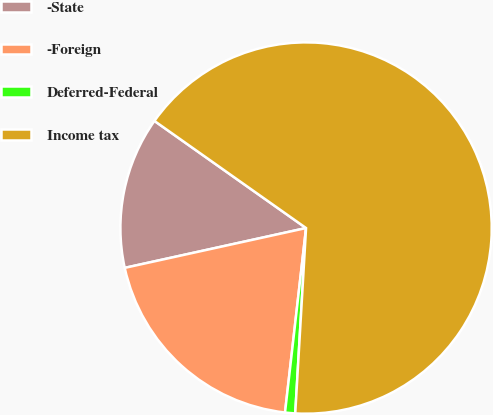Convert chart. <chart><loc_0><loc_0><loc_500><loc_500><pie_chart><fcel>-State<fcel>-Foreign<fcel>Deferred-Federal<fcel>Income tax<nl><fcel>13.23%<fcel>19.75%<fcel>0.88%<fcel>66.14%<nl></chart> 